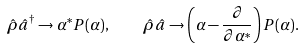<formula> <loc_0><loc_0><loc_500><loc_500>\hat { \rho } \hat { a } ^ { \dagger } \rightarrow \alpha ^ { * } P ( \alpha ) , \quad \hat { \rho } \hat { a } \rightarrow \left ( \alpha - \frac { \partial } { \partial \alpha ^ { * } } \right ) P ( \alpha ) .</formula> 